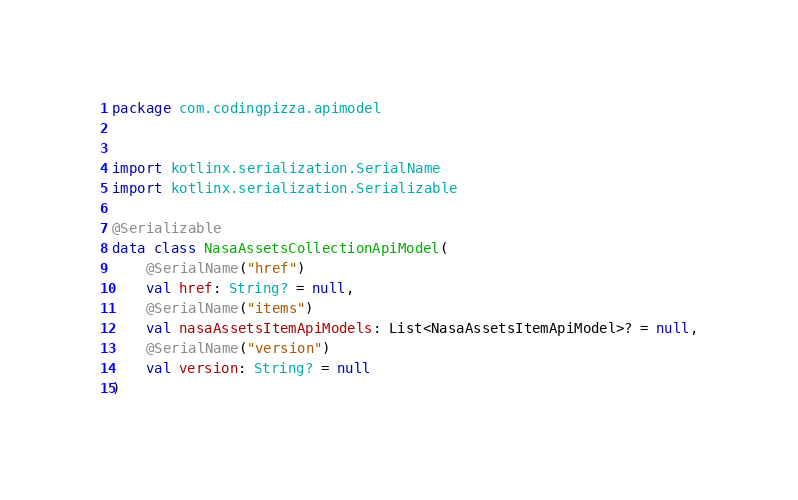Convert code to text. <code><loc_0><loc_0><loc_500><loc_500><_Kotlin_>package com.codingpizza.apimodel


import kotlinx.serialization.SerialName
import kotlinx.serialization.Serializable

@Serializable
data class NasaAssetsCollectionApiModel(
    @SerialName("href")
    val href: String? = null,
    @SerialName("items")
    val nasaAssetsItemApiModels: List<NasaAssetsItemApiModel>? = null,
    @SerialName("version")
    val version: String? = null
)</code> 